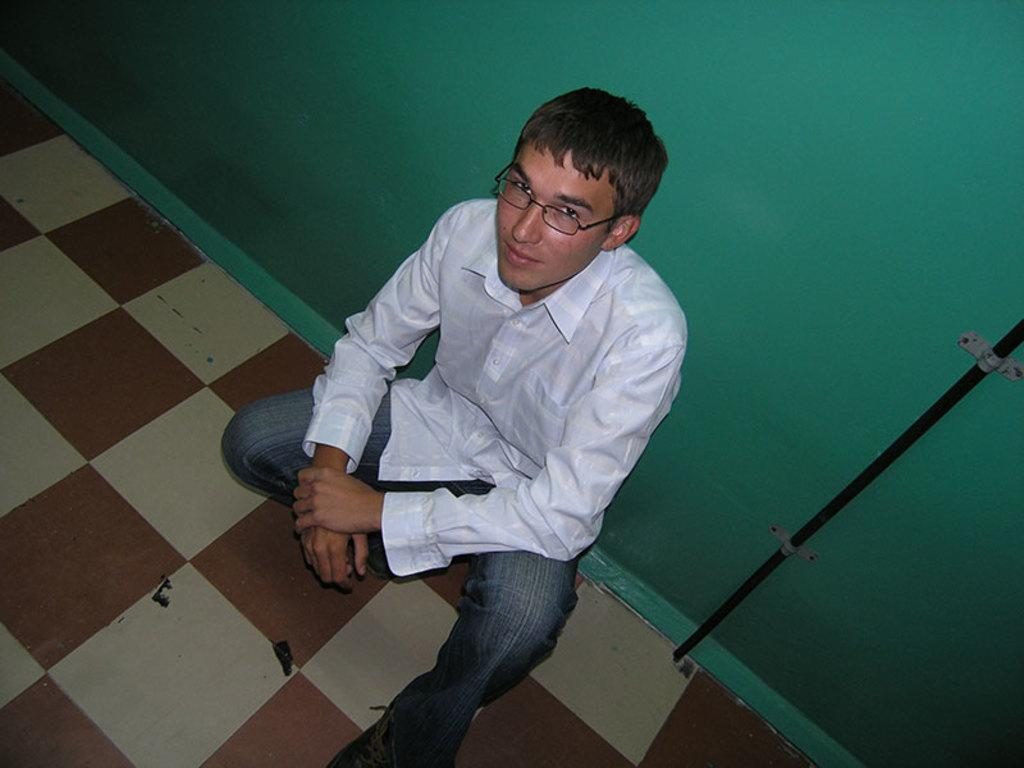Who is in the image? There is a man in the image. What position is the man in? The man is sitting in a squat position. What is the man wearing? The man is wearing a white shirt. What color is the wall behind the man? There is a green wall behind the man. What object can be seen in the image besides the man? There is a pipe visible in the image. What surface is the man sitting on? There is a floor in the image. What type of furniture is the man using to support himself while sitting in the image? There is no furniture present in the image; the man is sitting in a squat position on the floor. Can you see any celery in the image? There is no celery present in the image. 